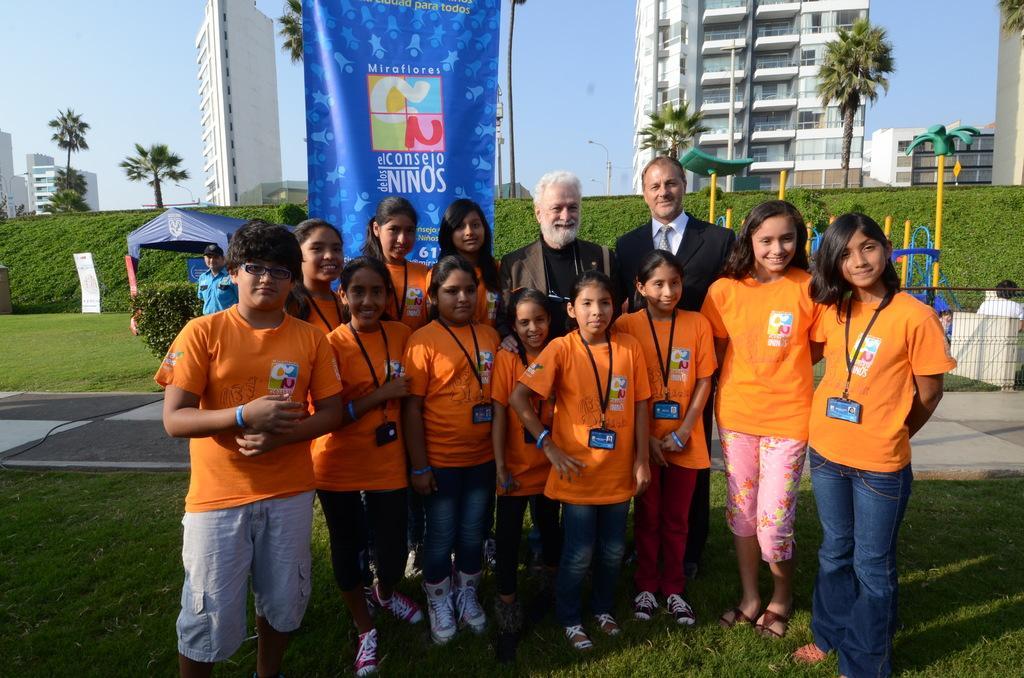In one or two sentences, can you explain what this image depicts? In this picture there are few kids wearing orange dress are standing on a greenery ground and there are two persons wearing suits are standing with them and there are buildings and trees in the background. 